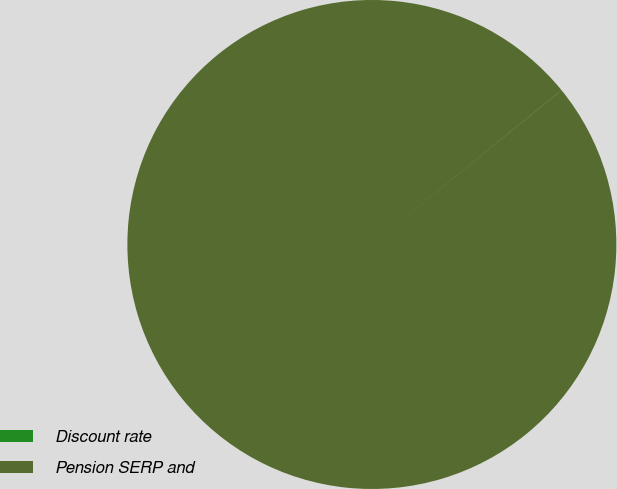<chart> <loc_0><loc_0><loc_500><loc_500><pie_chart><fcel>Discount rate<fcel>Pension SERP and<nl><fcel>0.01%<fcel>99.99%<nl></chart> 